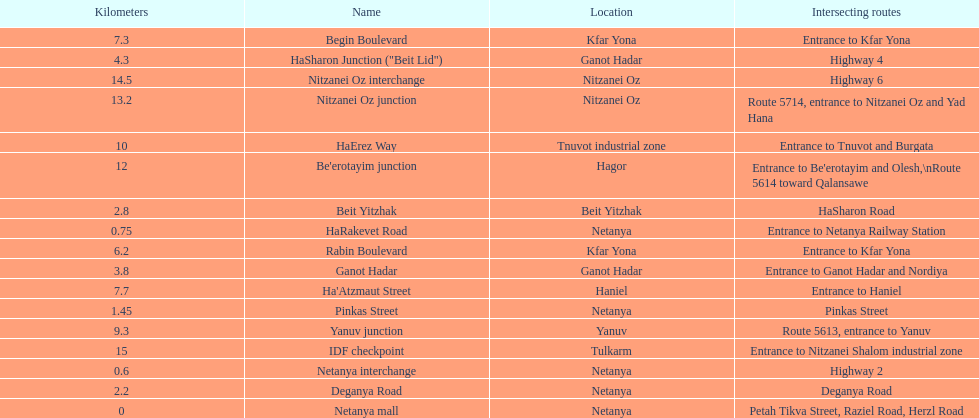Which location comes after kfar yona? Haniel. 